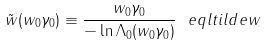<formula> <loc_0><loc_0><loc_500><loc_500>\tilde { w } ( w _ { 0 } \gamma _ { 0 } ) \equiv \frac { w _ { 0 } \gamma _ { 0 } } { - \ln \Lambda _ { 0 } ( w _ { 0 } \gamma _ { 0 } ) } \ e q l { t i l d e w }</formula> 